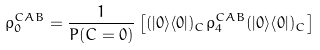Convert formula to latex. <formula><loc_0><loc_0><loc_500><loc_500>\rho _ { 0 } ^ { C A B } = \frac { 1 } { P ( C = 0 ) } \left [ ( | 0 \rangle \langle 0 | ) _ { C } \rho _ { 4 } ^ { C A B } ( | 0 \rangle \langle 0 | ) _ { C } \right ]</formula> 